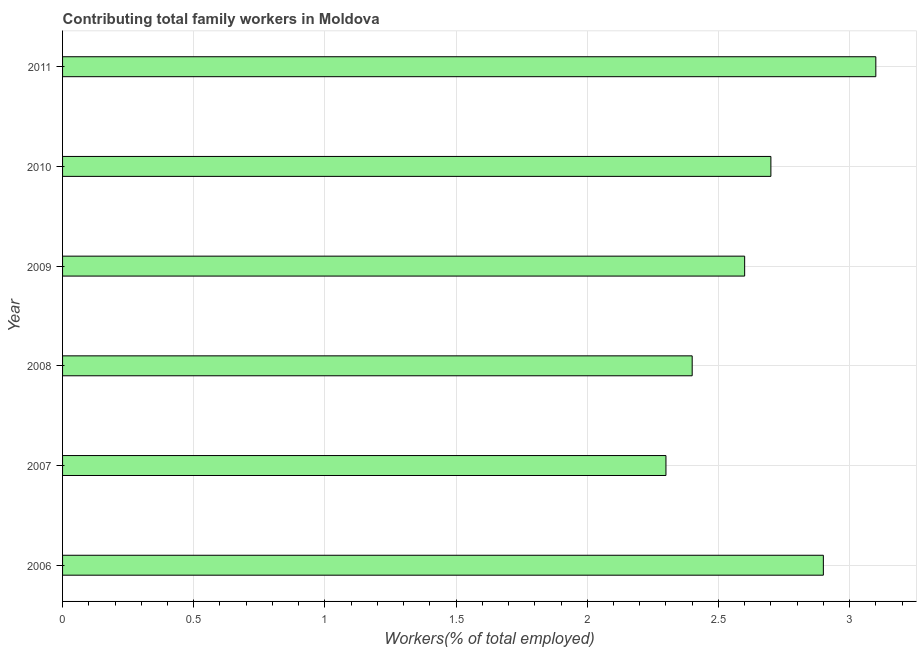What is the title of the graph?
Your answer should be very brief. Contributing total family workers in Moldova. What is the label or title of the X-axis?
Make the answer very short. Workers(% of total employed). What is the contributing family workers in 2010?
Give a very brief answer. 2.7. Across all years, what is the maximum contributing family workers?
Provide a succinct answer. 3.1. Across all years, what is the minimum contributing family workers?
Offer a very short reply. 2.3. What is the difference between the contributing family workers in 2008 and 2009?
Your answer should be compact. -0.2. What is the average contributing family workers per year?
Give a very brief answer. 2.67. What is the median contributing family workers?
Give a very brief answer. 2.65. Do a majority of the years between 2008 and 2009 (inclusive) have contributing family workers greater than 0.5 %?
Your answer should be compact. Yes. What is the ratio of the contributing family workers in 2007 to that in 2011?
Offer a very short reply. 0.74. Is the difference between the contributing family workers in 2006 and 2011 greater than the difference between any two years?
Your response must be concise. No. What is the difference between the highest and the second highest contributing family workers?
Provide a succinct answer. 0.2. What is the difference between the highest and the lowest contributing family workers?
Give a very brief answer. 0.8. In how many years, is the contributing family workers greater than the average contributing family workers taken over all years?
Ensure brevity in your answer.  3. How many bars are there?
Your answer should be very brief. 6. Are the values on the major ticks of X-axis written in scientific E-notation?
Make the answer very short. No. What is the Workers(% of total employed) of 2006?
Your answer should be compact. 2.9. What is the Workers(% of total employed) of 2007?
Make the answer very short. 2.3. What is the Workers(% of total employed) of 2008?
Make the answer very short. 2.4. What is the Workers(% of total employed) of 2009?
Provide a succinct answer. 2.6. What is the Workers(% of total employed) in 2010?
Your answer should be very brief. 2.7. What is the Workers(% of total employed) of 2011?
Your answer should be compact. 3.1. What is the difference between the Workers(% of total employed) in 2006 and 2009?
Provide a short and direct response. 0.3. What is the difference between the Workers(% of total employed) in 2006 and 2010?
Provide a succinct answer. 0.2. What is the difference between the Workers(% of total employed) in 2006 and 2011?
Give a very brief answer. -0.2. What is the difference between the Workers(% of total employed) in 2007 and 2008?
Give a very brief answer. -0.1. What is the difference between the Workers(% of total employed) in 2007 and 2011?
Your answer should be very brief. -0.8. What is the difference between the Workers(% of total employed) in 2008 and 2009?
Give a very brief answer. -0.2. What is the difference between the Workers(% of total employed) in 2008 and 2011?
Your response must be concise. -0.7. What is the difference between the Workers(% of total employed) in 2009 and 2010?
Keep it short and to the point. -0.1. What is the difference between the Workers(% of total employed) in 2009 and 2011?
Offer a terse response. -0.5. What is the difference between the Workers(% of total employed) in 2010 and 2011?
Give a very brief answer. -0.4. What is the ratio of the Workers(% of total employed) in 2006 to that in 2007?
Your answer should be compact. 1.26. What is the ratio of the Workers(% of total employed) in 2006 to that in 2008?
Give a very brief answer. 1.21. What is the ratio of the Workers(% of total employed) in 2006 to that in 2009?
Offer a very short reply. 1.11. What is the ratio of the Workers(% of total employed) in 2006 to that in 2010?
Ensure brevity in your answer.  1.07. What is the ratio of the Workers(% of total employed) in 2006 to that in 2011?
Provide a succinct answer. 0.94. What is the ratio of the Workers(% of total employed) in 2007 to that in 2008?
Give a very brief answer. 0.96. What is the ratio of the Workers(% of total employed) in 2007 to that in 2009?
Your response must be concise. 0.89. What is the ratio of the Workers(% of total employed) in 2007 to that in 2010?
Offer a terse response. 0.85. What is the ratio of the Workers(% of total employed) in 2007 to that in 2011?
Offer a terse response. 0.74. What is the ratio of the Workers(% of total employed) in 2008 to that in 2009?
Give a very brief answer. 0.92. What is the ratio of the Workers(% of total employed) in 2008 to that in 2010?
Keep it short and to the point. 0.89. What is the ratio of the Workers(% of total employed) in 2008 to that in 2011?
Your answer should be compact. 0.77. What is the ratio of the Workers(% of total employed) in 2009 to that in 2010?
Make the answer very short. 0.96. What is the ratio of the Workers(% of total employed) in 2009 to that in 2011?
Offer a very short reply. 0.84. What is the ratio of the Workers(% of total employed) in 2010 to that in 2011?
Provide a short and direct response. 0.87. 